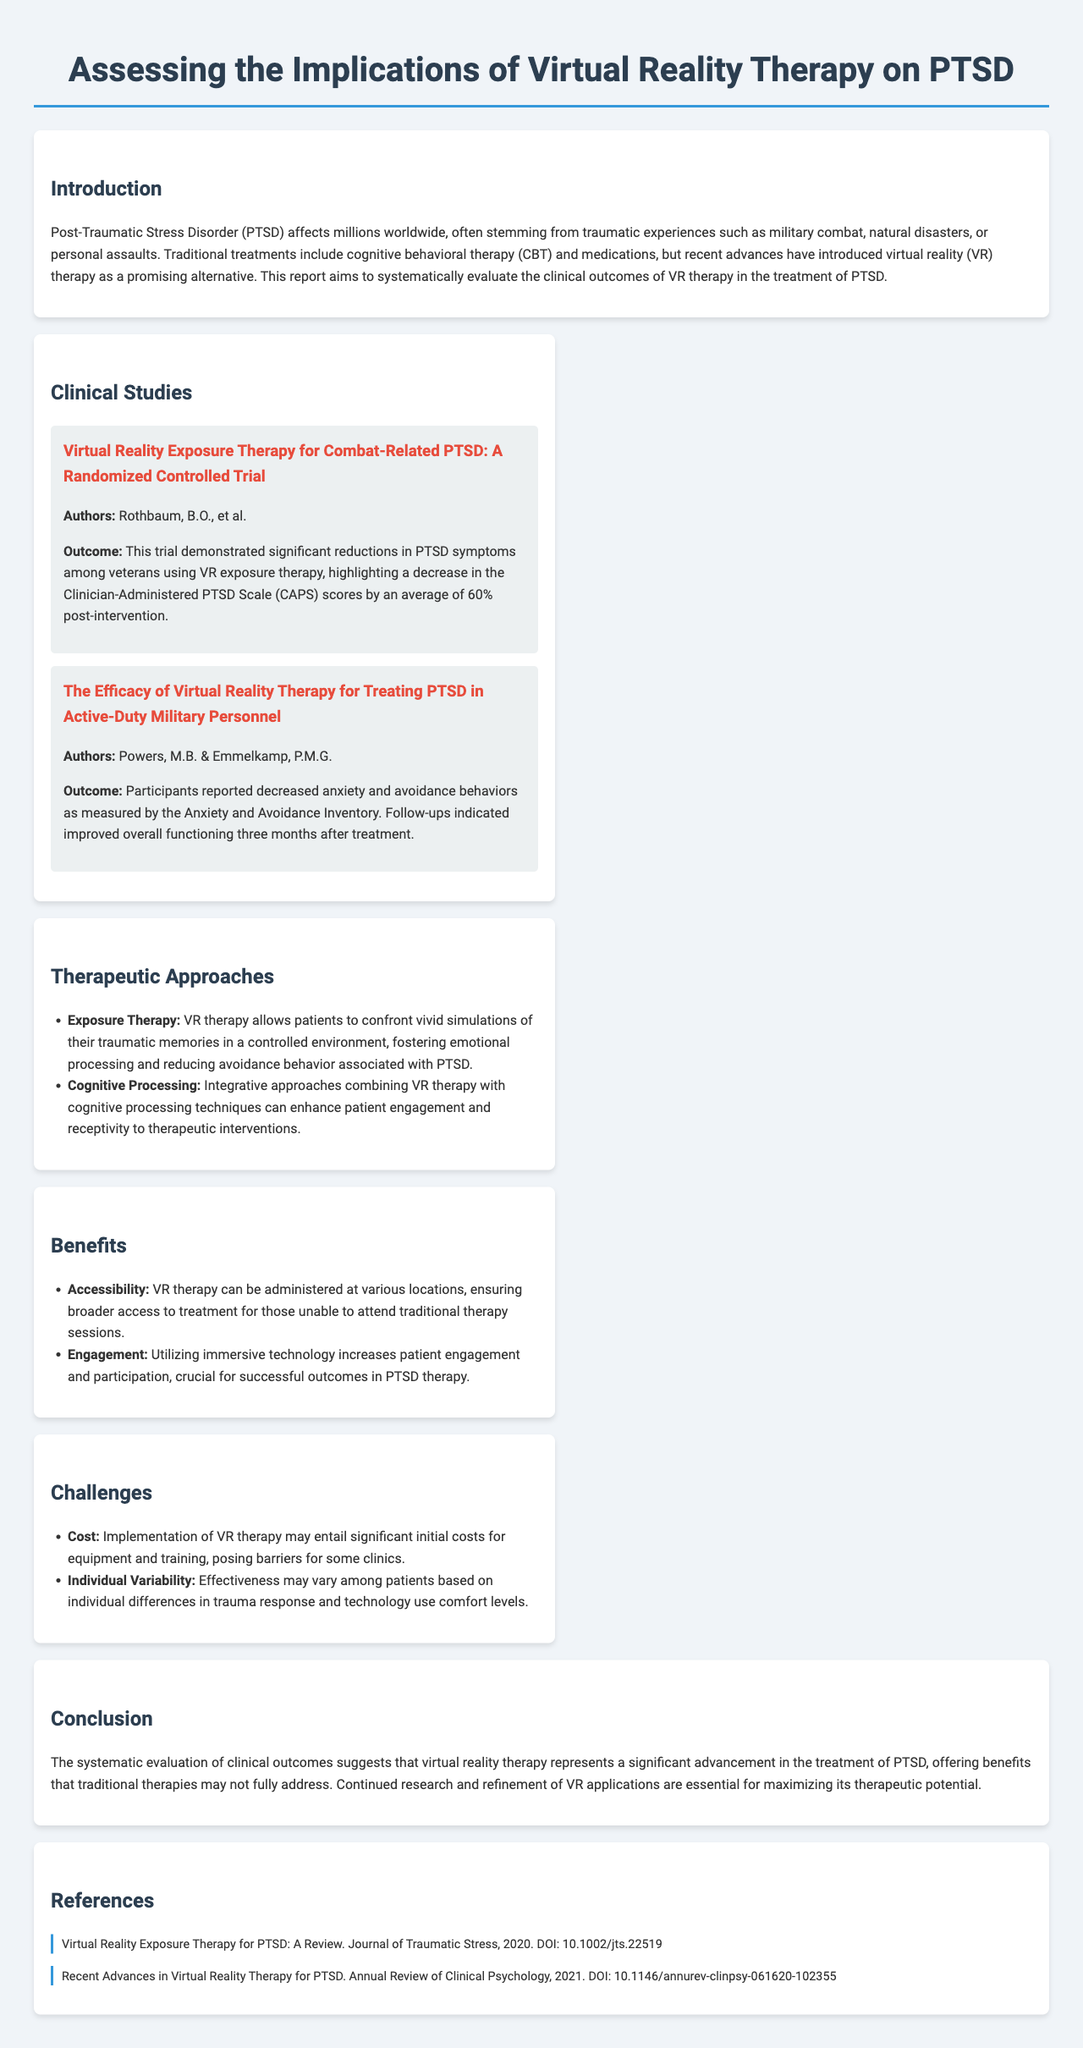What is the main focus of the report? The report systematically evaluates the clinical outcomes of VR therapy in the treatment of PTSD.
Answer: clinical outcomes of VR therapy in the treatment of PTSD Who is the author of the study on combat-related PTSD? The study titled "Virtual Reality Exposure Therapy for Combat-Related PTSD" was authored by Rothbaum, B.O., et al.
Answer: Rothbaum, B.O., et al What was the average decrease in CAPS scores reported after VR therapy? The trial demonstrated a decrease in CAPS scores by an average of 60% post-intervention.
Answer: 60% What are the two therapeutic approaches mentioned in the report? The report mentions Exposure Therapy and Cognitive Processing as therapeutic approaches.
Answer: Exposure Therapy and Cognitive Processing What is one benefit of VR therapy listed in the document? The document lists Accessibility as a benefit of VR therapy, allowing broader access to treatment.
Answer: Accessibility What challenge related to VR therapy is mentioned in the report? One challenge mentioned is Cost, which involves significant initial costs for equipment and training.
Answer: Cost How many clinical studies are summarized in the document? The document summarizes two clinical studies related to VR therapy for PTSD.
Answer: two What notable follow-up outcome was observed in the second study regarding participants' functioning? The follow-up indicated improved overall functioning three months after treatment.
Answer: improved overall functioning three months after treatment Which section of the report discusses the implications of the findings? The Conclusion section of the report discusses the implications of the findings related to VR therapy.
Answer: Conclusion 